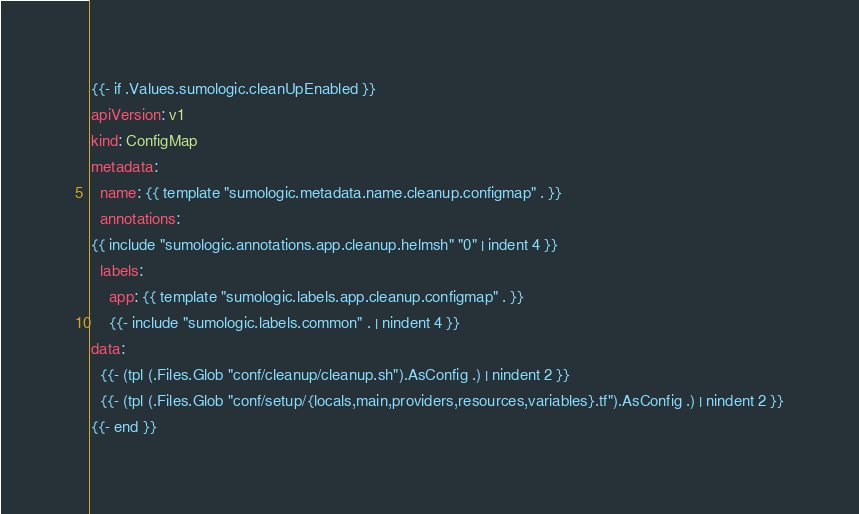<code> <loc_0><loc_0><loc_500><loc_500><_YAML_>{{- if .Values.sumologic.cleanUpEnabled }}
apiVersion: v1
kind: ConfigMap
metadata:
  name: {{ template "sumologic.metadata.name.cleanup.configmap" . }}
  annotations:
{{ include "sumologic.annotations.app.cleanup.helmsh" "0" | indent 4 }}
  labels:
    app: {{ template "sumologic.labels.app.cleanup.configmap" . }}
    {{- include "sumologic.labels.common" . | nindent 4 }}
data:
  {{- (tpl (.Files.Glob "conf/cleanup/cleanup.sh").AsConfig .) | nindent 2 }}
  {{- (tpl (.Files.Glob "conf/setup/{locals,main,providers,resources,variables}.tf").AsConfig .) | nindent 2 }}
{{- end }}
</code> 